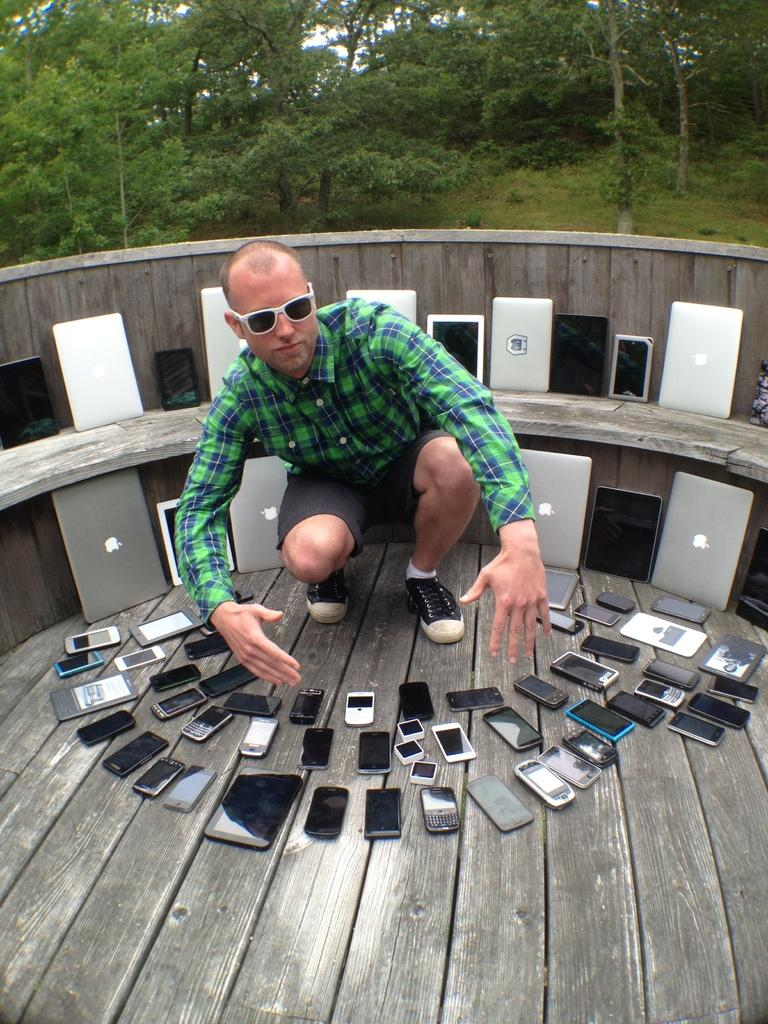Who is present in the image? There is a man in the image. What is the man doing in the image? The man is in a squat position. What accessory is the man wearing in the image? The man is wearing glasses. What else can be seen in the image besides the man? There are electronic gadgets and trees in the background of the image. What type of tongue can be seen in the image? There is no tongue present in the image. 